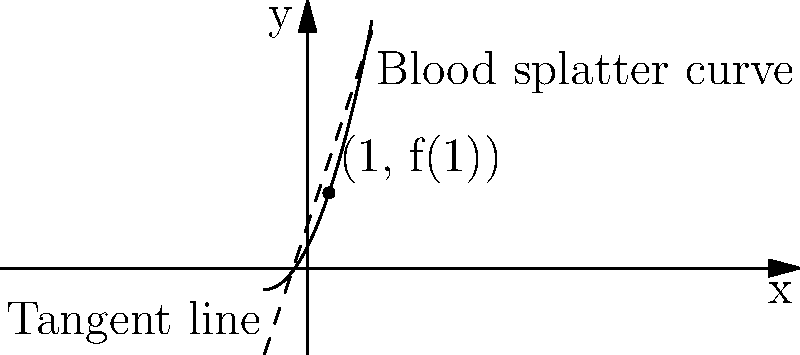In a crime scene, the blood splatter pattern follows the curve $f(x) = 0.5x^2 + 2x + 1$, where $x$ is the horizontal distance from the origin in meters, and $f(x)$ is the height of the blood splatter in meters. At the point where $x = 1$, determine the instantaneous rate of change of the blood splatter height with respect to the horizontal distance. Additionally, find the equation of the tangent line at this point. To solve this problem, we'll follow these steps:

1) First, we need to find the derivative of the function $f(x) = 0.5x^2 + 2x + 1$:
   $$f'(x) = x + 2$$

2) The instantaneous rate of change at $x = 1$ is given by $f'(1)$:
   $$f'(1) = 1 + 2 = 3$$

3) This means that at $x = 1$, the blood splatter height is changing at a rate of 3 meters per meter of horizontal distance.

4) To find the equation of the tangent line, we need:
   - The slope, which we just calculated: $m = f'(1) = 3$
   - A point on the line: $(1, f(1))$

5) Let's calculate $f(1)$:
   $$f(1) = 0.5(1)^2 + 2(1) + 1 = 0.5 + 2 + 1 = 3.5$$

6) Now we have a point $(1, 3.5)$ and the slope $m = 3$. We can use the point-slope form of a line:
   $$y - y_1 = m(x - x_1)$$
   $$y - 3.5 = 3(x - 1)$$

7) Simplify to slope-intercept form:
   $$y = 3x + 0.5$$

This is the equation of the tangent line at $x = 1$.
Answer: Instantaneous rate of change: 3 m/m. Tangent line equation: $y = 3x + 0.5$ 